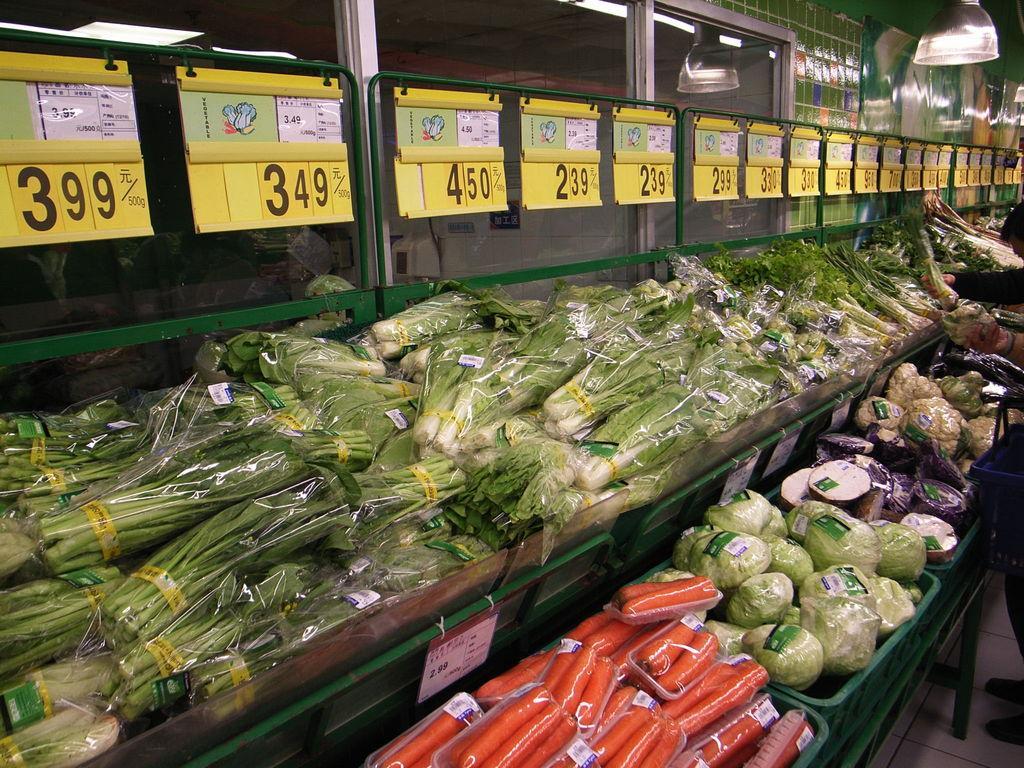Describe this image in one or two sentences. In this image, we can see vegetables are wrapping with cover and placed in racks and baskets. Top of the image, we can see glass, object and price stickers. On the right side of the image, we can see a human hand is holding a vegetable. Here a person is standing on the white floor. Through the glass we can see the inside view. Here we can see few things, ceiling and lights. 